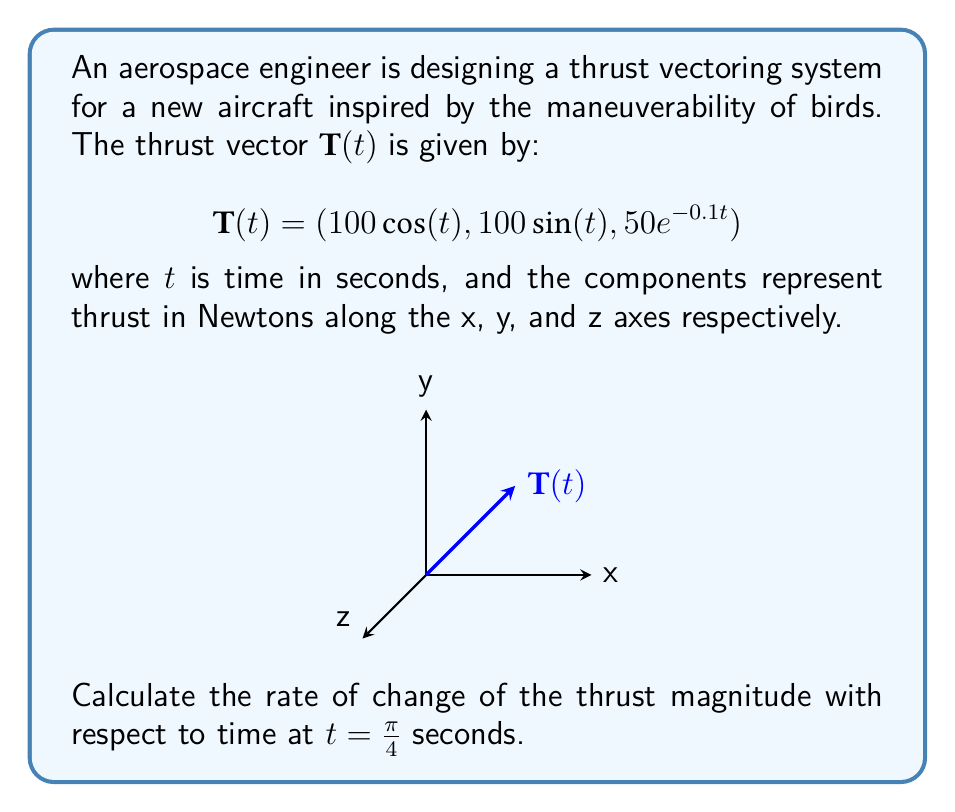Give your solution to this math problem. Let's approach this step-by-step:

1) The magnitude of the thrust vector at any time $t$ is given by:

   $$|\mathbf{T}(t)| = \sqrt{(100\cos(t))^2 + (100\sin(t))^2 + (50e^{-0.1t})^2}$$

2) To find the rate of change of the thrust magnitude, we need to differentiate this with respect to $t$:

   $$\frac{d}{dt}|\mathbf{T}(t)| = \frac{d}{dt}\sqrt{(100\cos(t))^2 + (100\sin(t))^2 + (50e^{-0.1t})^2}$$

3) Using the chain rule:

   $$\frac{d}{dt}|\mathbf{T}(t)| = \frac{1}{2\sqrt{(100\cos(t))^2 + (100\sin(t))^2 + (50e^{-0.1t})^2}} \cdot \frac{d}{dt}[(100\cos(t))^2 + (100\sin(t))^2 + (50e^{-0.1t})^2]$$

4) Differentiating the terms inside the square root:

   $$\frac{d}{dt}[(100\cos(t))^2 + (100\sin(t))^2 + (50e^{-0.1t})^2] = 2(100\cos(t))(-100\sin(t)) + 2(100\sin(t))(100\cos(t)) + 2(50e^{-0.1t})(-5e^{-0.1t})$$

   $$= -10000\sin(t)\cos(t) + 10000\sin(t)\cos(t) - 500e^{-0.2t}$$

   $$= -500e^{-0.2t}$$

5) Substituting this back into our expression:

   $$\frac{d}{dt}|\mathbf{T}(t)| = \frac{-500e^{-0.2t}}{2\sqrt{(100\cos(t))^2 + (100\sin(t))^2 + (50e^{-0.1t})^2}}$$

6) Now, we need to evaluate this at $t = \frac{\pi}{4}$:

   $$\frac{d}{dt}|\mathbf{T}(\frac{\pi}{4})| = \frac{-500e^{-0.2\frac{\pi}{4}}}{2\sqrt{(100\cos(\frac{\pi}{4}))^2 + (100\sin(\frac{\pi}{4}))^2 + (50e^{-0.1\frac{\pi}{4}})^2}}$$

7) Simplify:
   
   $$= \frac{-500e^{-0.2\frac{\pi}{4}}}{2\sqrt{(100\cdot\frac{\sqrt{2}}{2})^2 + (100\cdot\frac{\sqrt{2}}{2})^2 + (50e^{-0.1\frac{\pi}{4}})^2}}$$

   $$= \frac{-500e^{-0.2\frac{\pi}{4}}}{2\sqrt{10000 + (50e^{-0.1\frac{\pi}{4}})^2}}$$

8) Calculate the final value:

   $$\approx -2.4845 \text{ N/s}$$
Answer: $-2.4845 \text{ N/s}$ 